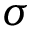Convert formula to latex. <formula><loc_0><loc_0><loc_500><loc_500>\sigma</formula> 